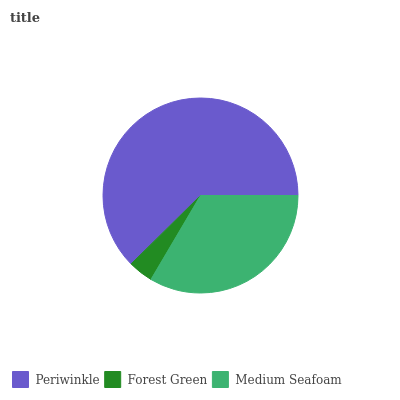Is Forest Green the minimum?
Answer yes or no. Yes. Is Periwinkle the maximum?
Answer yes or no. Yes. Is Medium Seafoam the minimum?
Answer yes or no. No. Is Medium Seafoam the maximum?
Answer yes or no. No. Is Medium Seafoam greater than Forest Green?
Answer yes or no. Yes. Is Forest Green less than Medium Seafoam?
Answer yes or no. Yes. Is Forest Green greater than Medium Seafoam?
Answer yes or no. No. Is Medium Seafoam less than Forest Green?
Answer yes or no. No. Is Medium Seafoam the high median?
Answer yes or no. Yes. Is Medium Seafoam the low median?
Answer yes or no. Yes. Is Periwinkle the high median?
Answer yes or no. No. Is Forest Green the low median?
Answer yes or no. No. 